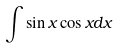<formula> <loc_0><loc_0><loc_500><loc_500>\int \sin x \cos x d x</formula> 